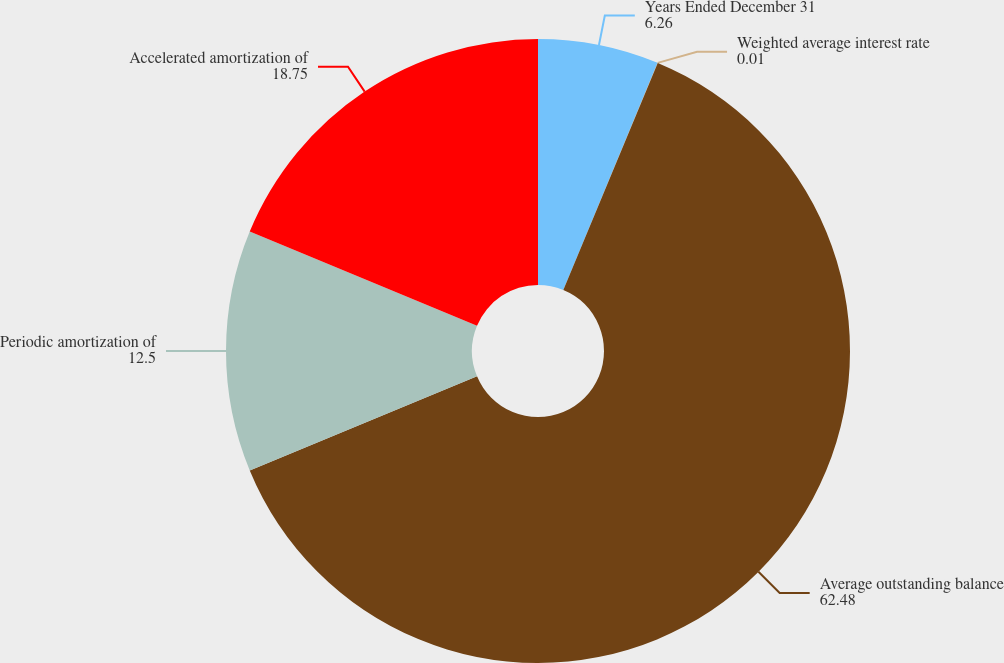Convert chart. <chart><loc_0><loc_0><loc_500><loc_500><pie_chart><fcel>Years Ended December 31<fcel>Weighted average interest rate<fcel>Average outstanding balance<fcel>Periodic amortization of<fcel>Accelerated amortization of<nl><fcel>6.26%<fcel>0.01%<fcel>62.48%<fcel>12.5%<fcel>18.75%<nl></chart> 